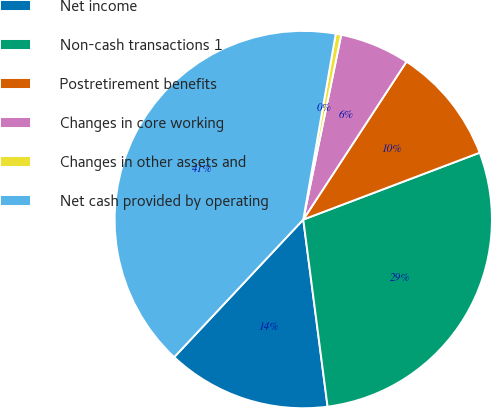Convert chart. <chart><loc_0><loc_0><loc_500><loc_500><pie_chart><fcel>Net income<fcel>Non-cash transactions 1<fcel>Postretirement benefits<fcel>Changes in core working<fcel>Changes in other assets and<fcel>Net cash provided by operating<nl><fcel>14.05%<fcel>28.71%<fcel>10.02%<fcel>5.99%<fcel>0.47%<fcel>40.76%<nl></chart> 